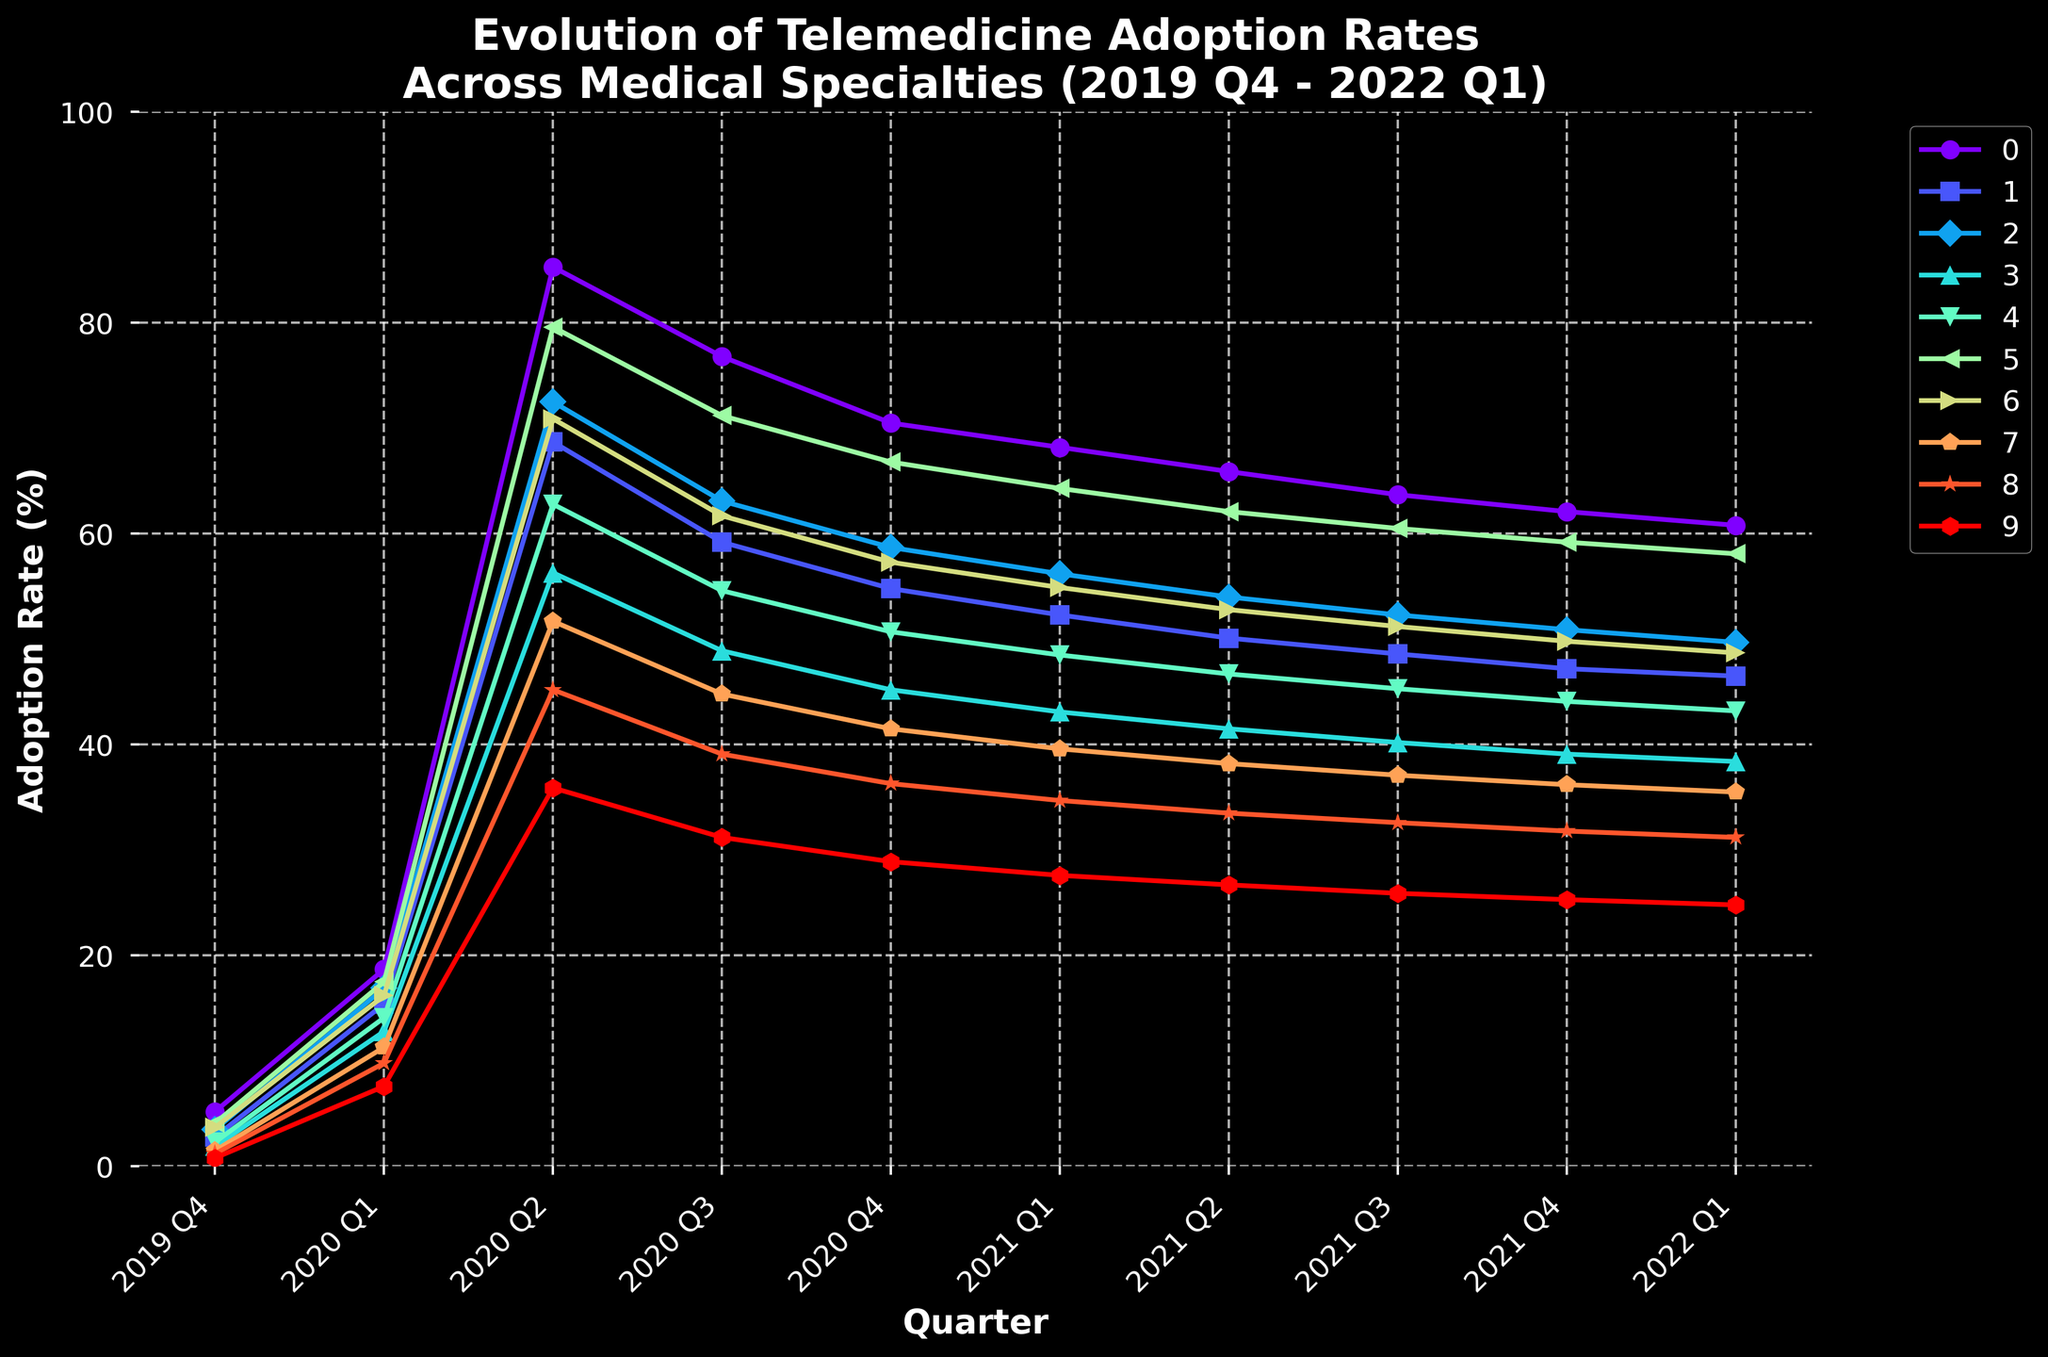What specialty had the highest telemedicine adoption rate in 2020 Q2? In 2020 Q2, looking at the peaks of the lines, Psychiatry shows the highest adoption rate at 85.3%.
Answer: Psychiatry Which specialty showed the least increase in adoption rate from 2020 Q1 to 2020 Q2? By comparing the increase in adoption rates between 2020 Q1 and 2020 Q2 for all specialties, Ophthalmology increases from 7.6% to 35.9%, which is the smallest increase of 28.3%.
Answer: Ophthalmology How did the adoption rate for Rheumatology change from 2020 Q2 to 2021 Q2? The adoption rate for Rheumatology in 2020 Q2 was 62.8% and in 2021 Q2 it was 46.7%. The change is a decrease of 62.8% - 46.7% = 16.1%.
Answer: 16.1% decrease Which specialties had a higher telemedicine adoption rate than Dermatology in 2022 Q1? In 2022 Q1, Dermatology had an adoption rate of 58.1%. Psychiatry (60.8%) was the only specialty higher than Dermatology.
Answer: Psychiatry What is the average adoption rate for Primary Care across all quarters shown? Adding the adoption rates for Primary Care across all quarters and dividing by 10 gives (3.7 + 16.2 + 70.9 + 61.7 + 57.3 + 54.9 + 52.8 + 51.2 + 49.8 + 48.7) / 10 = 46.72%.
Answer: 46.72% Which specialty exhibited the steepest decline in telemedicine adoption from its peak value to the end of the observed period? Psychiatry peaks at 85.3% in 2020 Q2 and decreases to 60.8% in 2022 Q1. The decline is 85.3% - 60.8% = 24.5%, which is the steepest among all specialties.
Answer: Psychiatry How many specialties had their highest adoption rate in 2020 Q2? Observing the peaks in 2020 Q2, Psychiatry, Endocrinology, Neurology, Cardiology, Rheumatology, Dermatology, Primary Care, Oncology, Orthopedics, and Ophthalmology all had their highest rates. All 10 specialties peaked in 2020 Q2.
Answer: 10 Which specialties show a continuous decline in telemedicine adoption from 2020 Q2 to 2022 Q1? Looking at the trends, Psychiatry, Endocrinology, Neurology, Cardiology, Rheumatology, Dermatology, Primary Care, Oncology, Orthopedics, and Ophthalmology show a continuous decline after 2020 Q2.
Answer: All specialties Between Neurology and Oncology, which specialty had a higher initial adoption rate in 2019 Q4 and by how much? Neurology started at 3.5% and Oncology at 1.5% in 2019 Q4. The difference is 3.5% - 1.5% = 2%.
Answer: Neurology by 2% Compare the trend lines of Psychiatry and Dermatology from 2020 Q3 to 2021 Q3. How do they compare in terms of their slope and general trend? Psychiatry starts at 76.8% in 2020 Q3 and decreases to 63.7% in 2021 Q3. Dermatology starts at 71.2% in 2020 Q3 and decreases to 60.5% in 2021 Q3. Both show a downward trend, but Psychiatry declines by 13.1% while Dermatology declines by 10.7%, indicating Psychiatry's steeper slope.
Answer: Psychiatry declines more steeply than Dermatology 